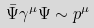Convert formula to latex. <formula><loc_0><loc_0><loc_500><loc_500>\bar { \Psi } \gamma ^ { \mu } \Psi \sim p ^ { \mu }</formula> 